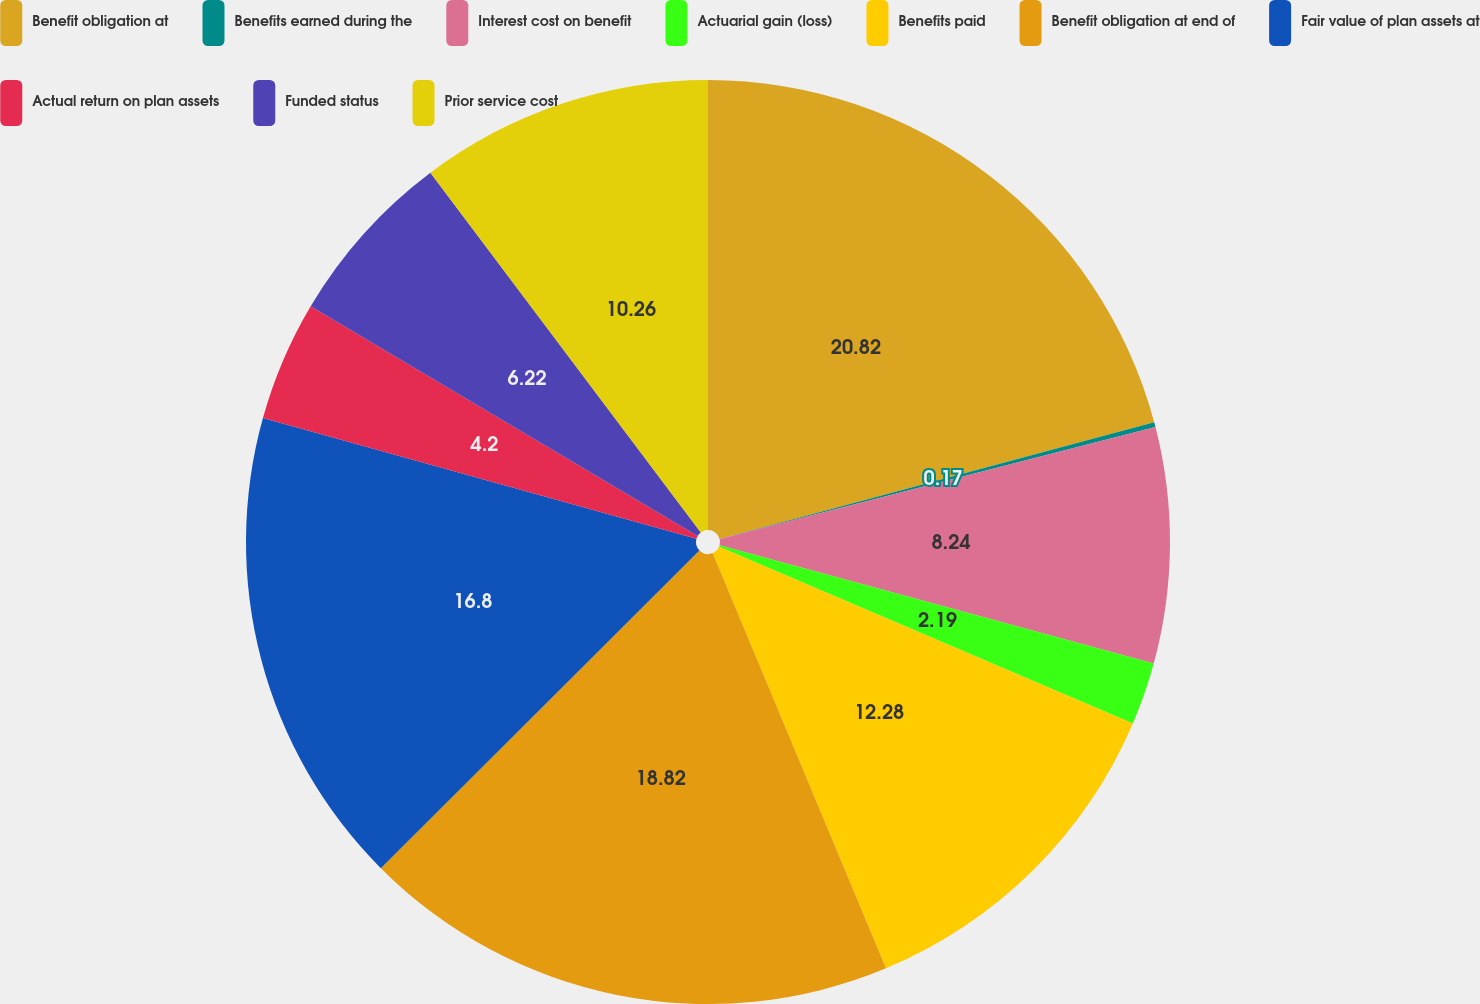Convert chart. <chart><loc_0><loc_0><loc_500><loc_500><pie_chart><fcel>Benefit obligation at<fcel>Benefits earned during the<fcel>Interest cost on benefit<fcel>Actuarial gain (loss)<fcel>Benefits paid<fcel>Benefit obligation at end of<fcel>Fair value of plan assets at<fcel>Actual return on plan assets<fcel>Funded status<fcel>Prior service cost<nl><fcel>20.83%<fcel>0.17%<fcel>8.24%<fcel>2.19%<fcel>12.28%<fcel>18.82%<fcel>16.8%<fcel>4.2%<fcel>6.22%<fcel>10.26%<nl></chart> 